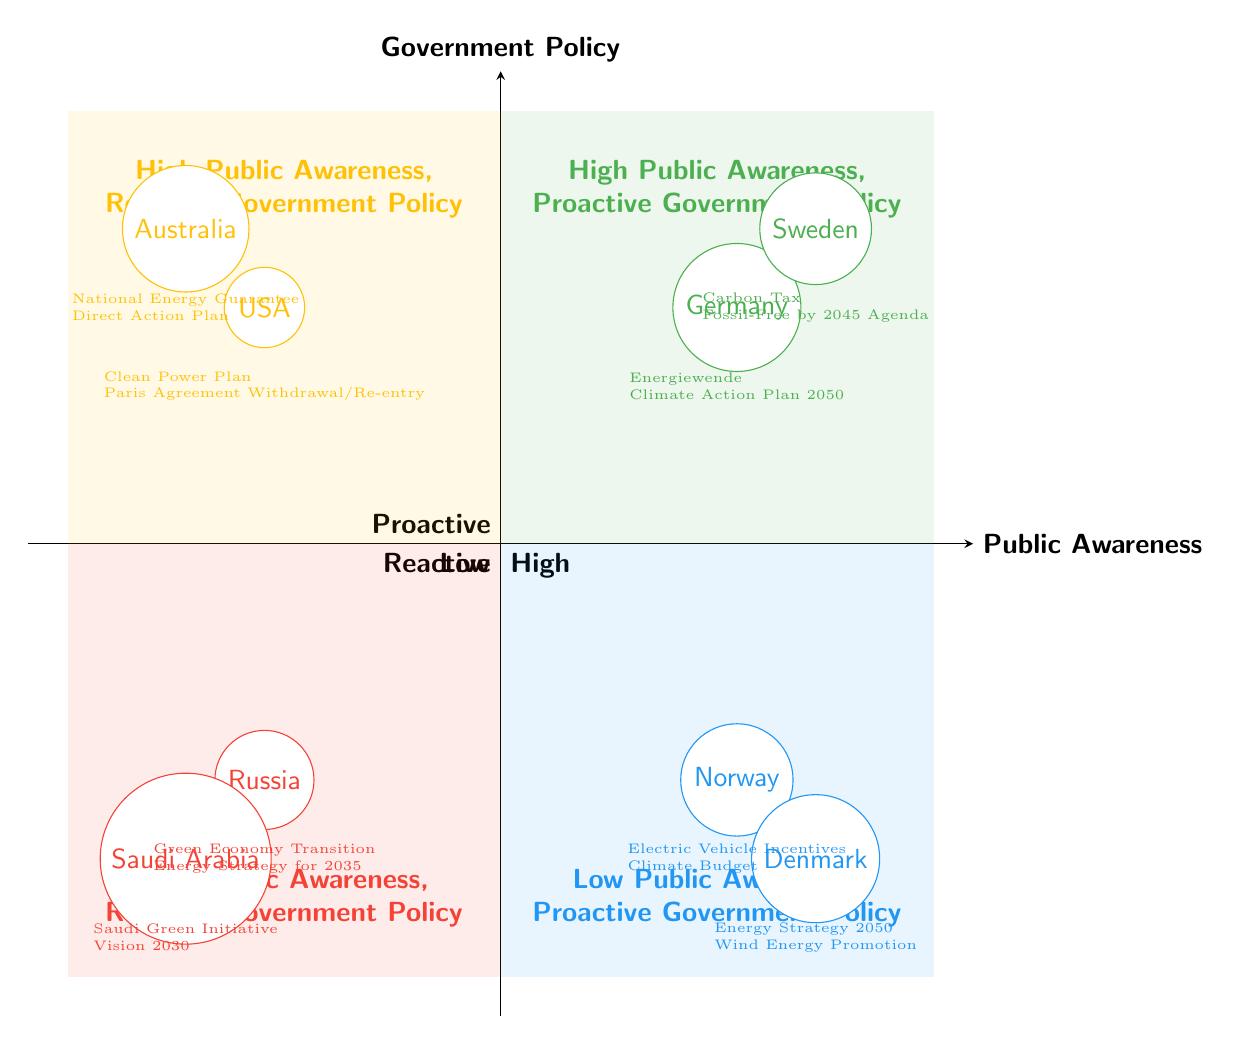What countries are in Quadrant 1? Quadrant 1 is labeled "High Public Awareness, Proactive Government Policy." From this quadrant, the countries included are Germany and Sweden, as they both show high public awareness and proactive government policies.
Answer: Germany, Sweden Which country has the policy "Carbon Tax"? The policy "Carbon Tax" is listed under Sweden, located in Quadrant 1, which indicates high public awareness and proactive government policy.
Answer: Sweden How many countries show low public awareness and proactive government policy? Quadrant 3 represents countries with low public awareness and proactive government policy, and it contains two countries: Norway and Denmark. Thus, the total number of countries in this category is two.
Answer: 2 What is a specific policy from Australia? Looking into Quadrant 2, which represents high public awareness and reactive government policy, Australia has the policy "National Energy Guarantee." Thus, this specific policy relates to Australia's approach to its climate policy amid public awareness.
Answer: National Energy Guarantee Which quadrant contains Russia? Russia is situated in Quadrant 4, which is defined as having low public awareness and reactive government policy. This includes its policies, such as "Green Economy Transition" and "Energy Strategy for 2035."
Answer: Quadrant 4 Which country has proactive government policy but low public awareness? Norway, located in Quadrant 3, is an example of a country that manifests proactive government policies such as "Electric Vehicle Incentives" while displaying low public awareness.
Answer: Norway What type of government policy does Sweden have? Sweden is positioned in Quadrant 1, where the government policies are proactive. Specific policies there include the "Carbon Tax" and "Fossil-Free by 2045 Agenda." This classification indicates a commitment to actively addressing climate change.
Answer: Proactive How many reactive policies are listed for Russia? In Quadrant 4, Russia has two listed reactive policies: "Green Economy Transition" and "Energy Strategy for 2035." Therefore, the total number of reactive policies specified for Russia is two.
Answer: 2 Which of the following countries is associated with a "Climate Action Plan 2050"? The "Climate Action Plan 2050" is a specific policy linked to Germany. Since Germany is in Quadrant 1, it emphasizes the country's proactive approach to climate change amidst high public awareness.
Answer: Germany 